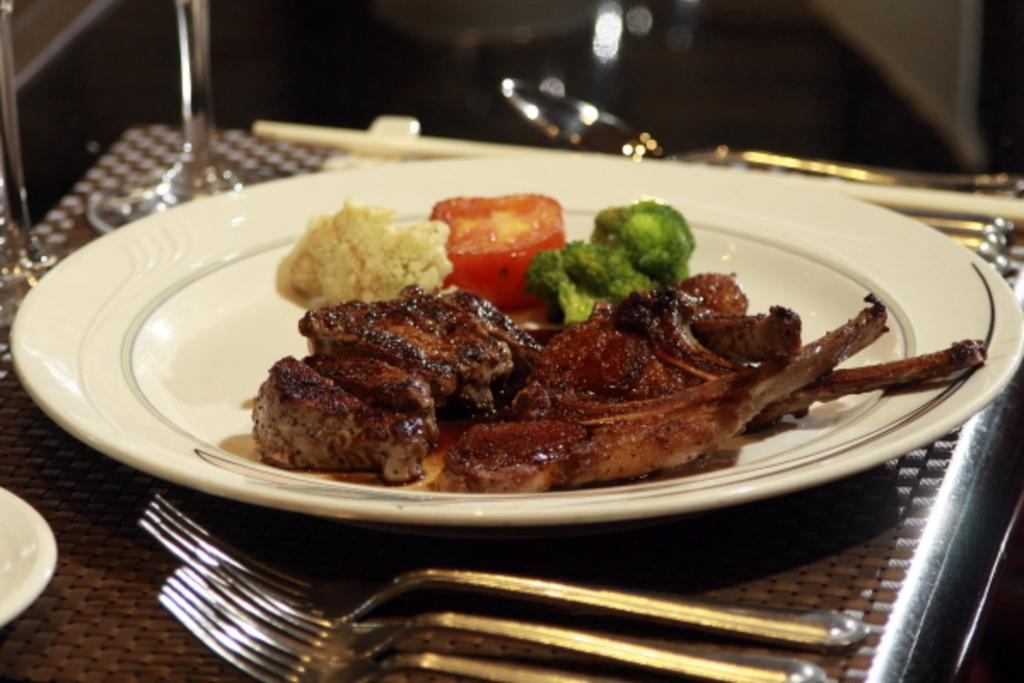What is on the table in the image? There is a plate on the table in the image. What is on the plate? There is meat on the plate. What utensils are present on the table? There are forks on the table. What type of ray can be seen swimming in the background of the image? There is no ray present in the image; it features a plate with meat and forks on a table. 